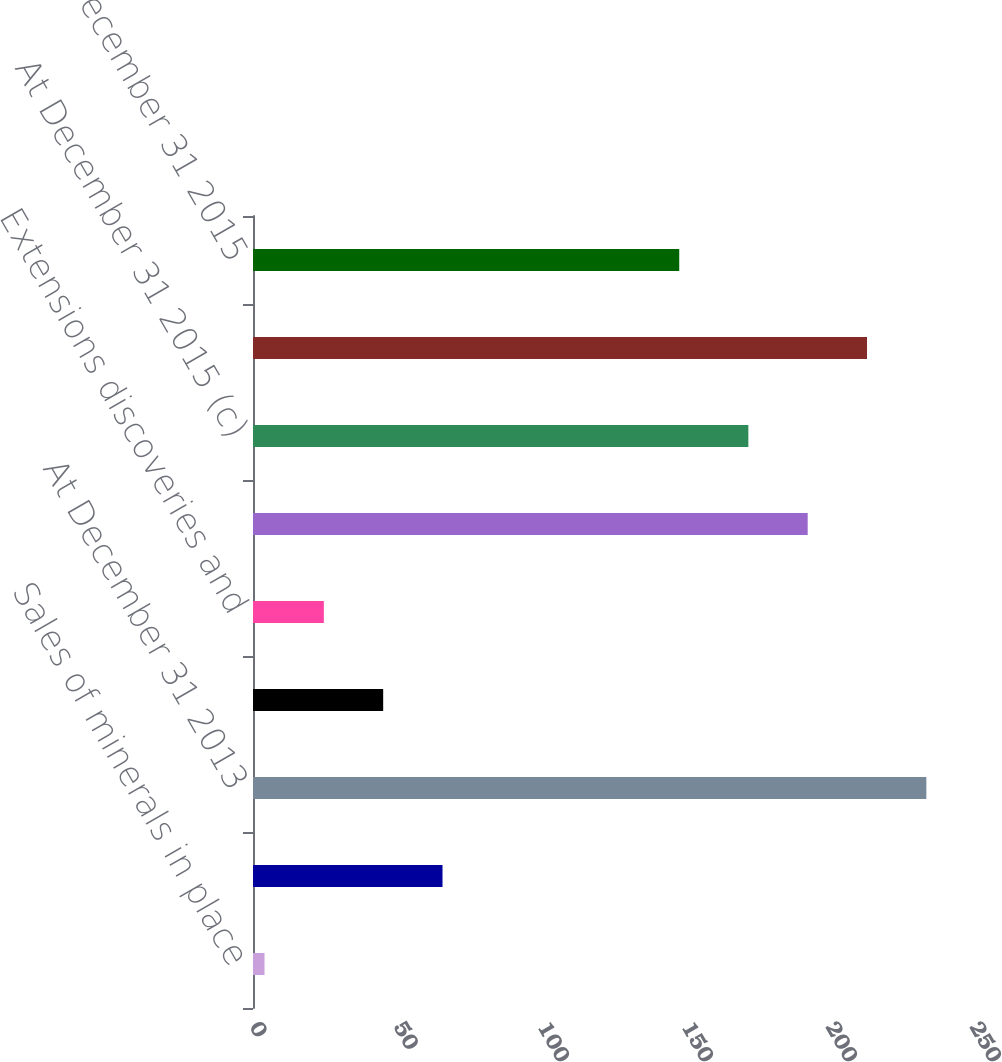Convert chart to OTSL. <chart><loc_0><loc_0><loc_500><loc_500><bar_chart><fcel>Sales of minerals in place<fcel>Production (f)<fcel>At December 31 2013<fcel>Revisions of previous<fcel>Extensions discoveries and<fcel>At December 31 2014<fcel>At December 31 2015 (c)<fcel>At January 1 2013<fcel>At December 31 2015<nl><fcel>4<fcel>65.8<fcel>233.8<fcel>45.2<fcel>24.6<fcel>192.6<fcel>172<fcel>213.2<fcel>148<nl></chart> 